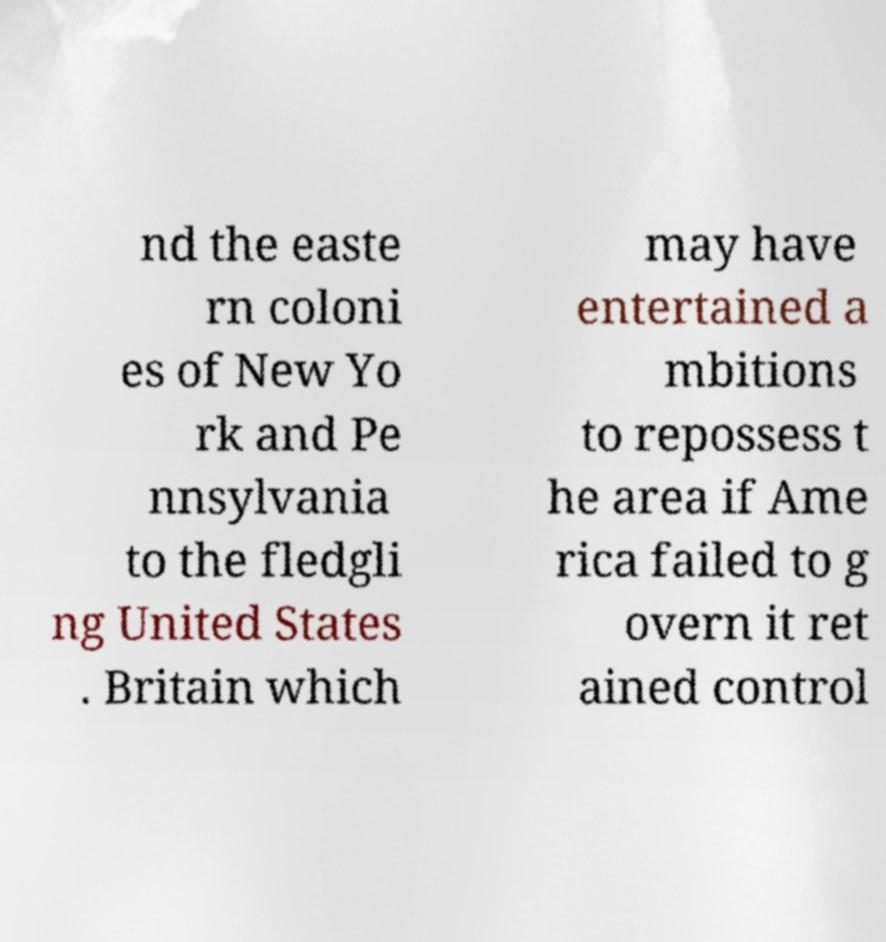What messages or text are displayed in this image? I need them in a readable, typed format. nd the easte rn coloni es of New Yo rk and Pe nnsylvania to the fledgli ng United States . Britain which may have entertained a mbitions to repossess t he area if Ame rica failed to g overn it ret ained control 